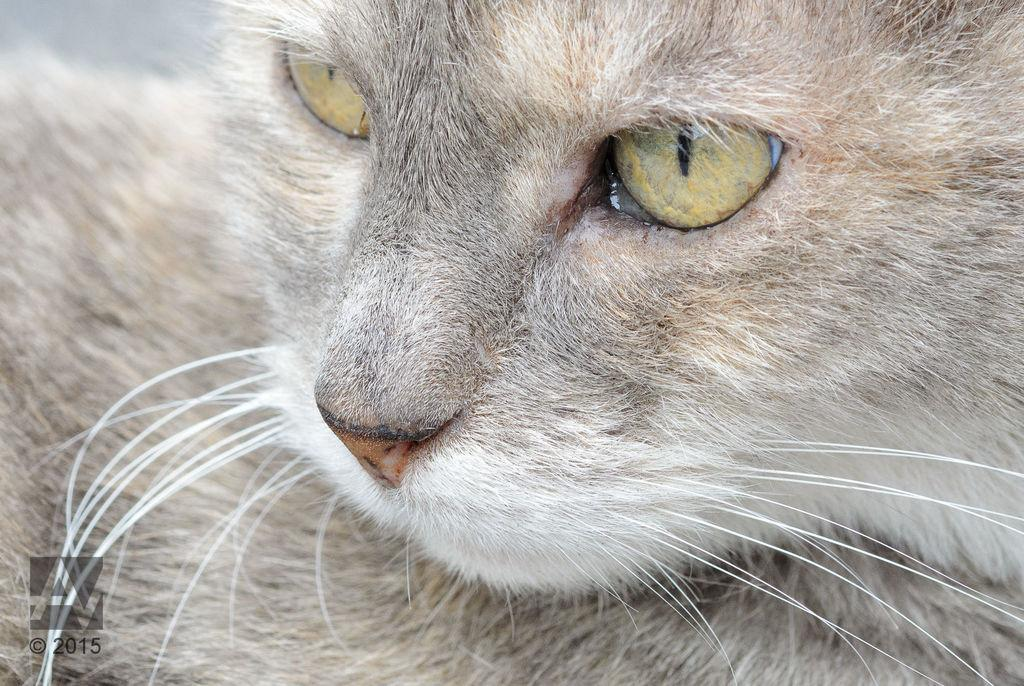What type of animal is in the picture? There is a cat in the picture. What is the cat doing in the picture? The cat is sitting. What color is the cat? The cat is grey in color. In which direction is the cat looking? The cat is looking to the left side. What type of support can be seen under the cat in the image? There is no visible support under the cat in the image; it appears to be sitting on the ground or a surface. 